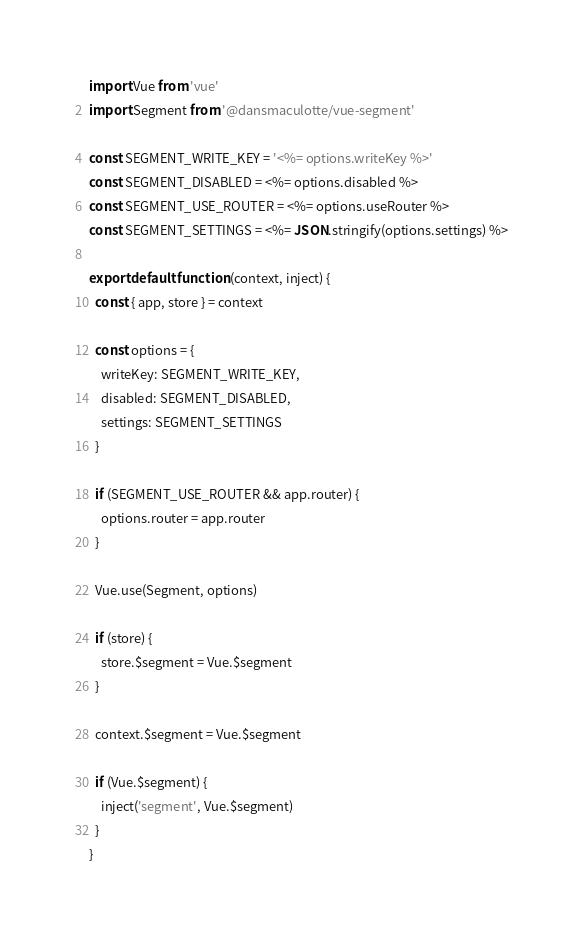Convert code to text. <code><loc_0><loc_0><loc_500><loc_500><_JavaScript_>import Vue from 'vue'
import Segment from '@dansmaculotte/vue-segment'

const SEGMENT_WRITE_KEY = '<%= options.writeKey %>'
const SEGMENT_DISABLED = <%= options.disabled %>
const SEGMENT_USE_ROUTER = <%= options.useRouter %>
const SEGMENT_SETTINGS = <%= JSON.stringify(options.settings) %>

export default function (context, inject) {
  const { app, store } = context

  const options = {
    writeKey: SEGMENT_WRITE_KEY,
    disabled: SEGMENT_DISABLED,
    settings: SEGMENT_SETTINGS
  }

  if (SEGMENT_USE_ROUTER && app.router) {
    options.router = app.router
  }

  Vue.use(Segment, options)

  if (store) {
    store.$segment = Vue.$segment
  }

  context.$segment = Vue.$segment

  if (Vue.$segment) {
    inject('segment', Vue.$segment)
  }
}
</code> 